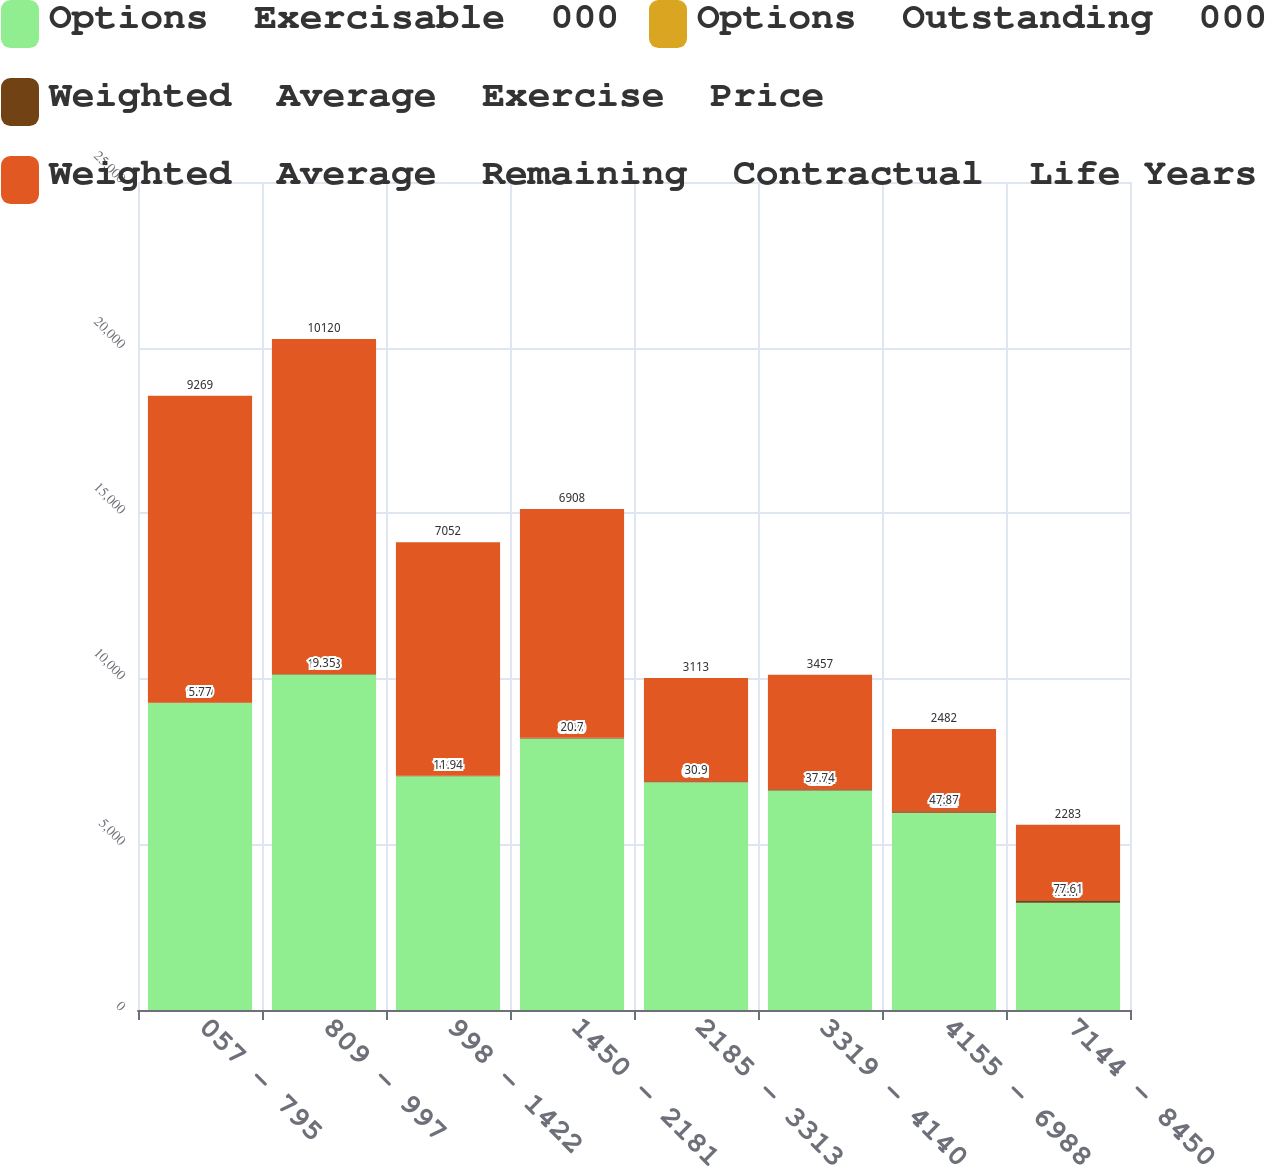Convert chart. <chart><loc_0><loc_0><loc_500><loc_500><stacked_bar_chart><ecel><fcel>057 - 795<fcel>809 - 997<fcel>998 - 1422<fcel>1450 - 2181<fcel>2185 - 3313<fcel>3319 - 4140<fcel>4155 - 6988<fcel>7144 - 8450<nl><fcel>Options  Exercisable  000<fcel>9269<fcel>10128<fcel>7054<fcel>8190<fcel>6871<fcel>6620<fcel>5944<fcel>3229<nl><fcel>Options  Outstanding  000<fcel>2.01<fcel>4.37<fcel>4.15<fcel>6.46<fcel>8.12<fcel>7.9<fcel>8.28<fcel>7.11<nl><fcel>Weighted  Average  Exercise  Price<fcel>5.77<fcel>9.35<fcel>11.94<fcel>20.7<fcel>30.9<fcel>37.74<fcel>47.87<fcel>77.61<nl><fcel>Weighted  Average  Remaining  Contractual  Life Years<fcel>9269<fcel>10120<fcel>7052<fcel>6908<fcel>3113<fcel>3457<fcel>2482<fcel>2283<nl></chart> 